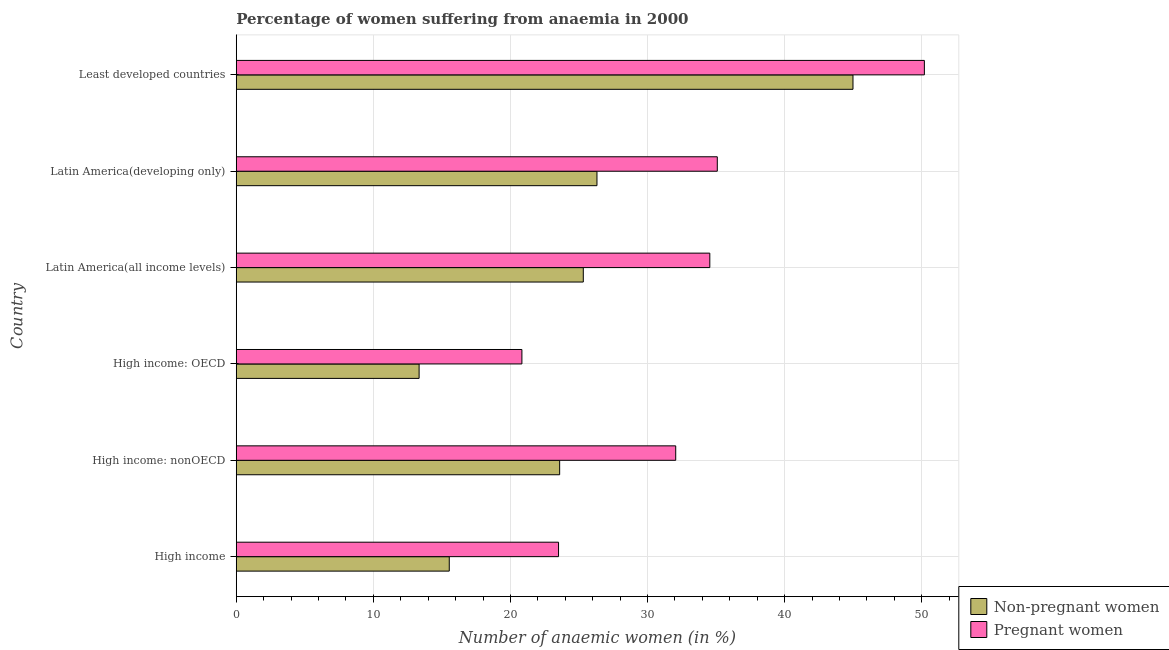How many different coloured bars are there?
Give a very brief answer. 2. How many groups of bars are there?
Your answer should be compact. 6. Are the number of bars per tick equal to the number of legend labels?
Offer a terse response. Yes. Are the number of bars on each tick of the Y-axis equal?
Offer a terse response. Yes. How many bars are there on the 2nd tick from the top?
Your response must be concise. 2. What is the label of the 6th group of bars from the top?
Offer a very short reply. High income. What is the percentage of pregnant anaemic women in High income: nonOECD?
Offer a terse response. 32.06. Across all countries, what is the maximum percentage of non-pregnant anaemic women?
Your response must be concise. 44.99. Across all countries, what is the minimum percentage of pregnant anaemic women?
Provide a succinct answer. 20.84. In which country was the percentage of pregnant anaemic women maximum?
Provide a succinct answer. Least developed countries. In which country was the percentage of non-pregnant anaemic women minimum?
Offer a terse response. High income: OECD. What is the total percentage of non-pregnant anaemic women in the graph?
Keep it short and to the point. 149.09. What is the difference between the percentage of pregnant anaemic women in Latin America(developing only) and that in Least developed countries?
Give a very brief answer. -15.11. What is the difference between the percentage of pregnant anaemic women in High income: OECD and the percentage of non-pregnant anaemic women in High income: nonOECD?
Your answer should be very brief. -2.75. What is the average percentage of pregnant anaemic women per country?
Offer a terse response. 32.71. What is the difference between the percentage of pregnant anaemic women and percentage of non-pregnant anaemic women in Least developed countries?
Ensure brevity in your answer.  5.21. What is the ratio of the percentage of non-pregnant anaemic women in High income: OECD to that in Least developed countries?
Give a very brief answer. 0.3. Is the difference between the percentage of pregnant anaemic women in Latin America(developing only) and Least developed countries greater than the difference between the percentage of non-pregnant anaemic women in Latin America(developing only) and Least developed countries?
Provide a succinct answer. Yes. What is the difference between the highest and the second highest percentage of pregnant anaemic women?
Give a very brief answer. 15.11. What is the difference between the highest and the lowest percentage of non-pregnant anaemic women?
Ensure brevity in your answer.  31.65. In how many countries, is the percentage of non-pregnant anaemic women greater than the average percentage of non-pregnant anaemic women taken over all countries?
Give a very brief answer. 3. Is the sum of the percentage of non-pregnant anaemic women in High income: OECD and Latin America(developing only) greater than the maximum percentage of pregnant anaemic women across all countries?
Your answer should be compact. No. What does the 2nd bar from the top in High income represents?
Keep it short and to the point. Non-pregnant women. What does the 2nd bar from the bottom in High income: OECD represents?
Give a very brief answer. Pregnant women. How many countries are there in the graph?
Your response must be concise. 6. What is the difference between two consecutive major ticks on the X-axis?
Your answer should be very brief. 10. Does the graph contain any zero values?
Offer a very short reply. No. Does the graph contain grids?
Ensure brevity in your answer.  Yes. Where does the legend appear in the graph?
Provide a short and direct response. Bottom right. How are the legend labels stacked?
Offer a very short reply. Vertical. What is the title of the graph?
Your answer should be very brief. Percentage of women suffering from anaemia in 2000. Does "Male" appear as one of the legend labels in the graph?
Offer a very short reply. No. What is the label or title of the X-axis?
Your answer should be compact. Number of anaemic women (in %). What is the label or title of the Y-axis?
Your answer should be compact. Country. What is the Number of anaemic women (in %) of Non-pregnant women in High income?
Your answer should be compact. 15.54. What is the Number of anaemic women (in %) of Pregnant women in High income?
Your answer should be compact. 23.51. What is the Number of anaemic women (in %) of Non-pregnant women in High income: nonOECD?
Give a very brief answer. 23.59. What is the Number of anaemic women (in %) of Pregnant women in High income: nonOECD?
Your response must be concise. 32.06. What is the Number of anaemic women (in %) of Non-pregnant women in High income: OECD?
Ensure brevity in your answer.  13.34. What is the Number of anaemic women (in %) of Pregnant women in High income: OECD?
Provide a succinct answer. 20.84. What is the Number of anaemic women (in %) of Non-pregnant women in Latin America(all income levels)?
Give a very brief answer. 25.32. What is the Number of anaemic women (in %) in Pregnant women in Latin America(all income levels)?
Ensure brevity in your answer.  34.55. What is the Number of anaemic women (in %) of Non-pregnant women in Latin America(developing only)?
Keep it short and to the point. 26.31. What is the Number of anaemic women (in %) in Pregnant women in Latin America(developing only)?
Provide a short and direct response. 35.09. What is the Number of anaemic women (in %) of Non-pregnant women in Least developed countries?
Give a very brief answer. 44.99. What is the Number of anaemic women (in %) in Pregnant women in Least developed countries?
Give a very brief answer. 50.2. Across all countries, what is the maximum Number of anaemic women (in %) in Non-pregnant women?
Make the answer very short. 44.99. Across all countries, what is the maximum Number of anaemic women (in %) in Pregnant women?
Provide a succinct answer. 50.2. Across all countries, what is the minimum Number of anaemic women (in %) of Non-pregnant women?
Provide a short and direct response. 13.34. Across all countries, what is the minimum Number of anaemic women (in %) in Pregnant women?
Give a very brief answer. 20.84. What is the total Number of anaemic women (in %) of Non-pregnant women in the graph?
Ensure brevity in your answer.  149.09. What is the total Number of anaemic women (in %) of Pregnant women in the graph?
Ensure brevity in your answer.  196.24. What is the difference between the Number of anaemic women (in %) in Non-pregnant women in High income and that in High income: nonOECD?
Offer a terse response. -8.05. What is the difference between the Number of anaemic women (in %) of Pregnant women in High income and that in High income: nonOECD?
Ensure brevity in your answer.  -8.55. What is the difference between the Number of anaemic women (in %) of Non-pregnant women in High income and that in High income: OECD?
Provide a succinct answer. 2.2. What is the difference between the Number of anaemic women (in %) in Pregnant women in High income and that in High income: OECD?
Your answer should be very brief. 2.67. What is the difference between the Number of anaemic women (in %) in Non-pregnant women in High income and that in Latin America(all income levels)?
Your response must be concise. -9.78. What is the difference between the Number of anaemic women (in %) of Pregnant women in High income and that in Latin America(all income levels)?
Provide a succinct answer. -11.04. What is the difference between the Number of anaemic women (in %) of Non-pregnant women in High income and that in Latin America(developing only)?
Offer a very short reply. -10.78. What is the difference between the Number of anaemic women (in %) of Pregnant women in High income and that in Latin America(developing only)?
Your answer should be very brief. -11.58. What is the difference between the Number of anaemic women (in %) of Non-pregnant women in High income and that in Least developed countries?
Provide a succinct answer. -29.45. What is the difference between the Number of anaemic women (in %) in Pregnant women in High income and that in Least developed countries?
Offer a terse response. -26.69. What is the difference between the Number of anaemic women (in %) in Non-pregnant women in High income: nonOECD and that in High income: OECD?
Your response must be concise. 10.25. What is the difference between the Number of anaemic women (in %) in Pregnant women in High income: nonOECD and that in High income: OECD?
Offer a very short reply. 11.22. What is the difference between the Number of anaemic women (in %) of Non-pregnant women in High income: nonOECD and that in Latin America(all income levels)?
Provide a short and direct response. -1.73. What is the difference between the Number of anaemic women (in %) in Pregnant women in High income: nonOECD and that in Latin America(all income levels)?
Offer a terse response. -2.49. What is the difference between the Number of anaemic women (in %) in Non-pregnant women in High income: nonOECD and that in Latin America(developing only)?
Offer a terse response. -2.72. What is the difference between the Number of anaemic women (in %) in Pregnant women in High income: nonOECD and that in Latin America(developing only)?
Provide a short and direct response. -3.03. What is the difference between the Number of anaemic women (in %) of Non-pregnant women in High income: nonOECD and that in Least developed countries?
Your answer should be very brief. -21.4. What is the difference between the Number of anaemic women (in %) of Pregnant women in High income: nonOECD and that in Least developed countries?
Offer a very short reply. -18.14. What is the difference between the Number of anaemic women (in %) in Non-pregnant women in High income: OECD and that in Latin America(all income levels)?
Your response must be concise. -11.98. What is the difference between the Number of anaemic women (in %) in Pregnant women in High income: OECD and that in Latin America(all income levels)?
Ensure brevity in your answer.  -13.71. What is the difference between the Number of anaemic women (in %) of Non-pregnant women in High income: OECD and that in Latin America(developing only)?
Give a very brief answer. -12.97. What is the difference between the Number of anaemic women (in %) of Pregnant women in High income: OECD and that in Latin America(developing only)?
Your answer should be compact. -14.25. What is the difference between the Number of anaemic women (in %) of Non-pregnant women in High income: OECD and that in Least developed countries?
Offer a terse response. -31.65. What is the difference between the Number of anaemic women (in %) of Pregnant women in High income: OECD and that in Least developed countries?
Ensure brevity in your answer.  -29.36. What is the difference between the Number of anaemic women (in %) of Non-pregnant women in Latin America(all income levels) and that in Latin America(developing only)?
Provide a short and direct response. -1. What is the difference between the Number of anaemic women (in %) of Pregnant women in Latin America(all income levels) and that in Latin America(developing only)?
Your answer should be very brief. -0.55. What is the difference between the Number of anaemic women (in %) in Non-pregnant women in Latin America(all income levels) and that in Least developed countries?
Offer a very short reply. -19.67. What is the difference between the Number of anaemic women (in %) of Pregnant women in Latin America(all income levels) and that in Least developed countries?
Keep it short and to the point. -15.65. What is the difference between the Number of anaemic women (in %) of Non-pregnant women in Latin America(developing only) and that in Least developed countries?
Your response must be concise. -18.68. What is the difference between the Number of anaemic women (in %) in Pregnant women in Latin America(developing only) and that in Least developed countries?
Keep it short and to the point. -15.11. What is the difference between the Number of anaemic women (in %) in Non-pregnant women in High income and the Number of anaemic women (in %) in Pregnant women in High income: nonOECD?
Keep it short and to the point. -16.52. What is the difference between the Number of anaemic women (in %) in Non-pregnant women in High income and the Number of anaemic women (in %) in Pregnant women in High income: OECD?
Make the answer very short. -5.3. What is the difference between the Number of anaemic women (in %) in Non-pregnant women in High income and the Number of anaemic women (in %) in Pregnant women in Latin America(all income levels)?
Your answer should be very brief. -19.01. What is the difference between the Number of anaemic women (in %) in Non-pregnant women in High income and the Number of anaemic women (in %) in Pregnant women in Latin America(developing only)?
Provide a succinct answer. -19.55. What is the difference between the Number of anaemic women (in %) in Non-pregnant women in High income and the Number of anaemic women (in %) in Pregnant women in Least developed countries?
Provide a short and direct response. -34.66. What is the difference between the Number of anaemic women (in %) in Non-pregnant women in High income: nonOECD and the Number of anaemic women (in %) in Pregnant women in High income: OECD?
Your answer should be compact. 2.75. What is the difference between the Number of anaemic women (in %) in Non-pregnant women in High income: nonOECD and the Number of anaemic women (in %) in Pregnant women in Latin America(all income levels)?
Ensure brevity in your answer.  -10.95. What is the difference between the Number of anaemic women (in %) in Non-pregnant women in High income: nonOECD and the Number of anaemic women (in %) in Pregnant women in Latin America(developing only)?
Your answer should be very brief. -11.5. What is the difference between the Number of anaemic women (in %) in Non-pregnant women in High income: nonOECD and the Number of anaemic women (in %) in Pregnant women in Least developed countries?
Ensure brevity in your answer.  -26.61. What is the difference between the Number of anaemic women (in %) of Non-pregnant women in High income: OECD and the Number of anaemic women (in %) of Pregnant women in Latin America(all income levels)?
Your answer should be compact. -21.21. What is the difference between the Number of anaemic women (in %) of Non-pregnant women in High income: OECD and the Number of anaemic women (in %) of Pregnant women in Latin America(developing only)?
Your answer should be compact. -21.75. What is the difference between the Number of anaemic women (in %) in Non-pregnant women in High income: OECD and the Number of anaemic women (in %) in Pregnant women in Least developed countries?
Your answer should be compact. -36.86. What is the difference between the Number of anaemic women (in %) of Non-pregnant women in Latin America(all income levels) and the Number of anaemic women (in %) of Pregnant women in Latin America(developing only)?
Provide a short and direct response. -9.78. What is the difference between the Number of anaemic women (in %) of Non-pregnant women in Latin America(all income levels) and the Number of anaemic women (in %) of Pregnant women in Least developed countries?
Provide a succinct answer. -24.88. What is the difference between the Number of anaemic women (in %) of Non-pregnant women in Latin America(developing only) and the Number of anaemic women (in %) of Pregnant women in Least developed countries?
Provide a short and direct response. -23.88. What is the average Number of anaemic women (in %) of Non-pregnant women per country?
Offer a terse response. 24.85. What is the average Number of anaemic women (in %) of Pregnant women per country?
Your answer should be compact. 32.71. What is the difference between the Number of anaemic women (in %) in Non-pregnant women and Number of anaemic women (in %) in Pregnant women in High income?
Provide a short and direct response. -7.97. What is the difference between the Number of anaemic women (in %) in Non-pregnant women and Number of anaemic women (in %) in Pregnant women in High income: nonOECD?
Your answer should be compact. -8.47. What is the difference between the Number of anaemic women (in %) of Non-pregnant women and Number of anaemic women (in %) of Pregnant women in High income: OECD?
Your answer should be compact. -7.5. What is the difference between the Number of anaemic women (in %) of Non-pregnant women and Number of anaemic women (in %) of Pregnant women in Latin America(all income levels)?
Provide a short and direct response. -9.23. What is the difference between the Number of anaemic women (in %) of Non-pregnant women and Number of anaemic women (in %) of Pregnant women in Latin America(developing only)?
Give a very brief answer. -8.78. What is the difference between the Number of anaemic women (in %) of Non-pregnant women and Number of anaemic women (in %) of Pregnant women in Least developed countries?
Keep it short and to the point. -5.21. What is the ratio of the Number of anaemic women (in %) in Non-pregnant women in High income to that in High income: nonOECD?
Give a very brief answer. 0.66. What is the ratio of the Number of anaemic women (in %) in Pregnant women in High income to that in High income: nonOECD?
Your response must be concise. 0.73. What is the ratio of the Number of anaemic women (in %) in Non-pregnant women in High income to that in High income: OECD?
Provide a short and direct response. 1.16. What is the ratio of the Number of anaemic women (in %) of Pregnant women in High income to that in High income: OECD?
Your response must be concise. 1.13. What is the ratio of the Number of anaemic women (in %) in Non-pregnant women in High income to that in Latin America(all income levels)?
Ensure brevity in your answer.  0.61. What is the ratio of the Number of anaemic women (in %) in Pregnant women in High income to that in Latin America(all income levels)?
Your response must be concise. 0.68. What is the ratio of the Number of anaemic women (in %) of Non-pregnant women in High income to that in Latin America(developing only)?
Provide a succinct answer. 0.59. What is the ratio of the Number of anaemic women (in %) in Pregnant women in High income to that in Latin America(developing only)?
Provide a short and direct response. 0.67. What is the ratio of the Number of anaemic women (in %) of Non-pregnant women in High income to that in Least developed countries?
Your answer should be very brief. 0.35. What is the ratio of the Number of anaemic women (in %) in Pregnant women in High income to that in Least developed countries?
Provide a succinct answer. 0.47. What is the ratio of the Number of anaemic women (in %) in Non-pregnant women in High income: nonOECD to that in High income: OECD?
Your answer should be compact. 1.77. What is the ratio of the Number of anaemic women (in %) in Pregnant women in High income: nonOECD to that in High income: OECD?
Give a very brief answer. 1.54. What is the ratio of the Number of anaemic women (in %) in Non-pregnant women in High income: nonOECD to that in Latin America(all income levels)?
Provide a succinct answer. 0.93. What is the ratio of the Number of anaemic women (in %) of Pregnant women in High income: nonOECD to that in Latin America(all income levels)?
Your answer should be very brief. 0.93. What is the ratio of the Number of anaemic women (in %) of Non-pregnant women in High income: nonOECD to that in Latin America(developing only)?
Your answer should be compact. 0.9. What is the ratio of the Number of anaemic women (in %) of Pregnant women in High income: nonOECD to that in Latin America(developing only)?
Your answer should be compact. 0.91. What is the ratio of the Number of anaemic women (in %) of Non-pregnant women in High income: nonOECD to that in Least developed countries?
Ensure brevity in your answer.  0.52. What is the ratio of the Number of anaemic women (in %) of Pregnant women in High income: nonOECD to that in Least developed countries?
Make the answer very short. 0.64. What is the ratio of the Number of anaemic women (in %) of Non-pregnant women in High income: OECD to that in Latin America(all income levels)?
Offer a terse response. 0.53. What is the ratio of the Number of anaemic women (in %) in Pregnant women in High income: OECD to that in Latin America(all income levels)?
Provide a succinct answer. 0.6. What is the ratio of the Number of anaemic women (in %) in Non-pregnant women in High income: OECD to that in Latin America(developing only)?
Give a very brief answer. 0.51. What is the ratio of the Number of anaemic women (in %) of Pregnant women in High income: OECD to that in Latin America(developing only)?
Offer a very short reply. 0.59. What is the ratio of the Number of anaemic women (in %) of Non-pregnant women in High income: OECD to that in Least developed countries?
Provide a succinct answer. 0.3. What is the ratio of the Number of anaemic women (in %) in Pregnant women in High income: OECD to that in Least developed countries?
Make the answer very short. 0.42. What is the ratio of the Number of anaemic women (in %) of Non-pregnant women in Latin America(all income levels) to that in Latin America(developing only)?
Give a very brief answer. 0.96. What is the ratio of the Number of anaemic women (in %) of Pregnant women in Latin America(all income levels) to that in Latin America(developing only)?
Your answer should be compact. 0.98. What is the ratio of the Number of anaemic women (in %) in Non-pregnant women in Latin America(all income levels) to that in Least developed countries?
Offer a very short reply. 0.56. What is the ratio of the Number of anaemic women (in %) in Pregnant women in Latin America(all income levels) to that in Least developed countries?
Make the answer very short. 0.69. What is the ratio of the Number of anaemic women (in %) of Non-pregnant women in Latin America(developing only) to that in Least developed countries?
Offer a terse response. 0.58. What is the ratio of the Number of anaemic women (in %) of Pregnant women in Latin America(developing only) to that in Least developed countries?
Offer a very short reply. 0.7. What is the difference between the highest and the second highest Number of anaemic women (in %) in Non-pregnant women?
Your answer should be very brief. 18.68. What is the difference between the highest and the second highest Number of anaemic women (in %) of Pregnant women?
Your answer should be very brief. 15.11. What is the difference between the highest and the lowest Number of anaemic women (in %) of Non-pregnant women?
Your answer should be compact. 31.65. What is the difference between the highest and the lowest Number of anaemic women (in %) in Pregnant women?
Offer a very short reply. 29.36. 